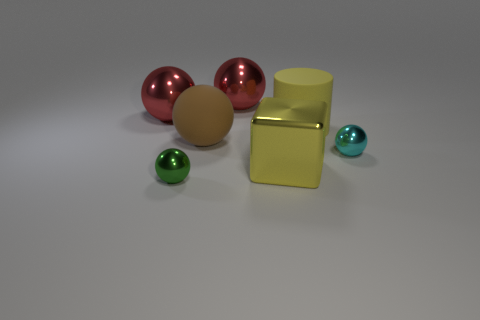There is a brown object that is the same shape as the small green metallic object; what is its size?
Your response must be concise. Large. Are there more tiny cyan balls on the left side of the big cylinder than red metal objects?
Ensure brevity in your answer.  No. Is the brown thing made of the same material as the large cube?
Keep it short and to the point. No. How many things are small shiny spheres that are in front of the tiny cyan metal ball or large red metal things on the right side of the big brown rubber object?
Your response must be concise. 2. There is a rubber thing that is the same shape as the cyan metallic object; what color is it?
Your answer should be compact. Brown. How many tiny shiny cylinders have the same color as the block?
Your response must be concise. 0. Is the color of the big matte cylinder the same as the big shiny block?
Your response must be concise. Yes. How many objects are either metal things that are to the left of the big yellow cube or small shiny objects?
Offer a terse response. 4. The small sphere in front of the sphere that is on the right side of the big shiny ball on the right side of the big brown rubber ball is what color?
Your answer should be very brief. Green. What is the color of the block that is made of the same material as the tiny green sphere?
Your response must be concise. Yellow. 